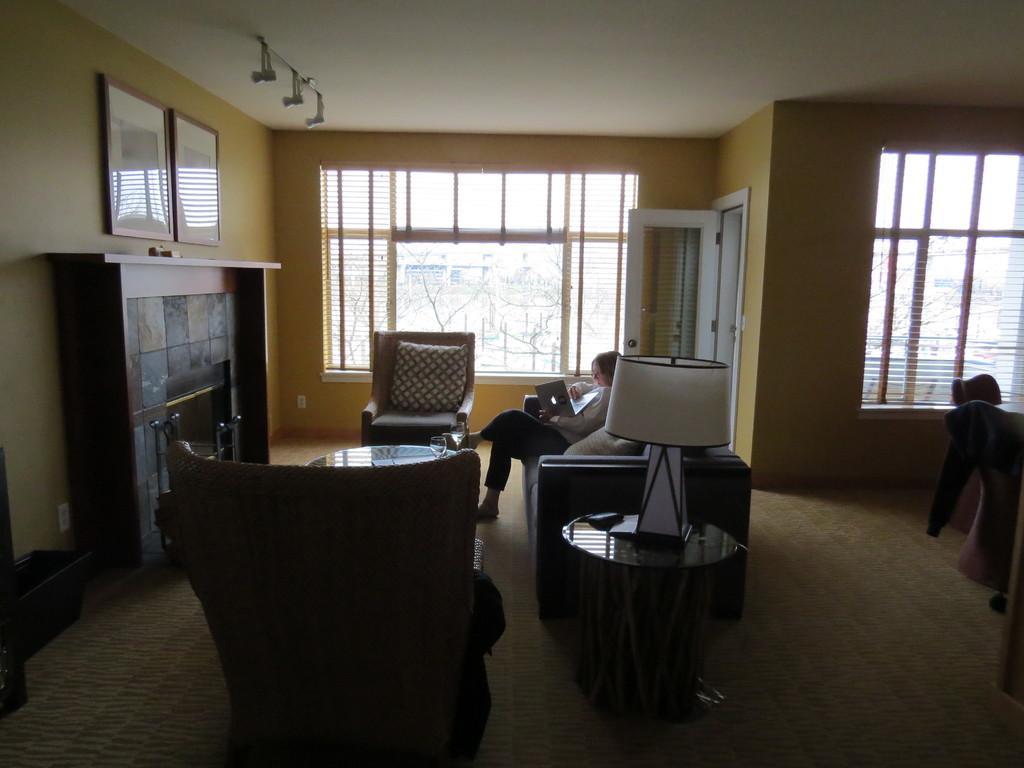How would you summarize this image in a sentence or two? In this image i can see a woman sitting on a couch holding a laptop, at left there is a cup board and few papers attached to it, there are two frames attached to a wall painted in yellow color, there are two couches in front of a woman,and a table at left there is a lamp on the table, there is a window, a wall at the back side. 